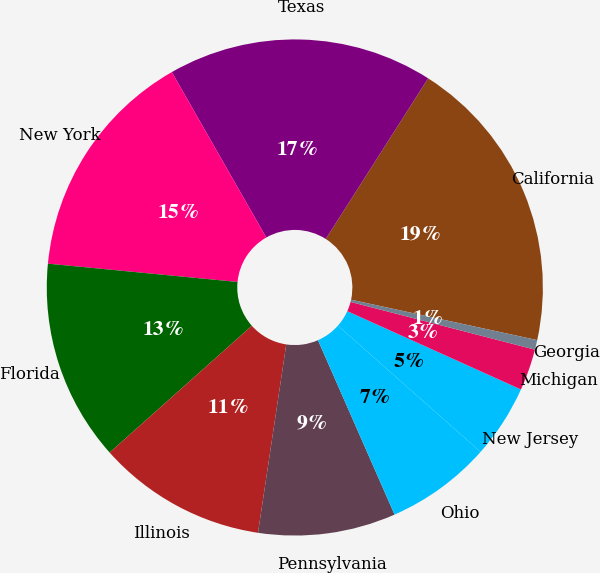Convert chart to OTSL. <chart><loc_0><loc_0><loc_500><loc_500><pie_chart><fcel>California<fcel>Texas<fcel>New York<fcel>Florida<fcel>Illinois<fcel>Pennsylvania<fcel>Ohio<fcel>New Jersey<fcel>Michigan<fcel>Georgia<nl><fcel>19.37%<fcel>17.29%<fcel>15.21%<fcel>13.12%<fcel>11.04%<fcel>8.96%<fcel>6.88%<fcel>4.79%<fcel>2.71%<fcel>0.63%<nl></chart> 